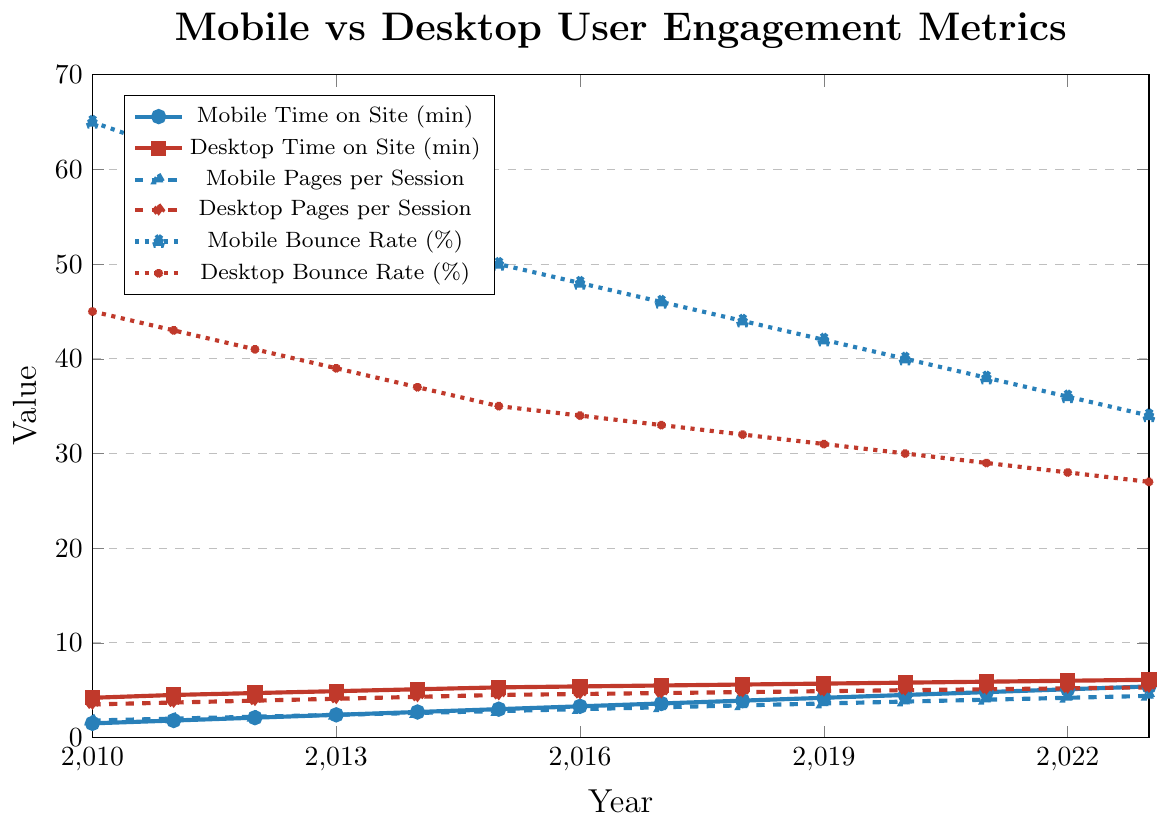What is the trend for mobile time on site from 2010 to 2023? The line chart shows an upward trend for mobile time on site from 1.5 minutes in 2010 to 5.4 minutes in 2023.
Answer: Increasing trend Which year had the smallest difference between mobile and desktop time on site? The difference between mobile and desktop time on site can be calculated for each year. The smallest difference is in 2023, where mobile time on site is 5.4 minutes and desktop is 6.1 minutes (difference of 0.7 minutes).
Answer: 2023 Between 2010 and 2023, which platform saw a larger reduction in bounce rate, mobile or desktop? The bounce rate for mobile decreased from 65% in 2010 to 34% in 2023 (31% reduction), while desktop decreased from 45% in 2010 to 27% in 2023 (18% reduction). Mobile saw a larger reduction.
Answer: Mobile What is the average pages per session for mobile users in 2023? The chart shows that the pages per session for mobile users in 2023 is 4.4.
Answer: 4.4 pages Compare the trend in bounce rates for mobile and desktop users over the years. Both mobile and desktop bounce rates show a downward trend from 2010 to 2023. Mobile bounce rate decreased from 65% to 34%, and desktop from 45% to 27%.
Answer: Downward trend for both What is the visual difference between mobile and desktop pages per session in 2015? The figure shows that in 2015, mobile pages per session is marked with a small triangle at 2.8, and desktop pages per session with a diamond at 4.5.
Answer: Mobile: 2.8, Desktop: 4.5 Is the time on site for desktop always higher than that for mobile across the years? The figure indicates that desktop time on site is consistently higher than mobile time on site from 2010 to 2023.
Answer: Yes Calculate the average bounce rate for mobile users over the entire period shown. Sum the mobile bounce rates from each year: 65 + 62 + 59 + 56 + 53 + 50 + 48 + 46 + 44 + 42 + 40 + 38 + 36 + 34 = 673. There are 14 years, so the average is 673 / 14.
Answer: 48.07% What year saw mobile pages per session surpass 3 for the first time? The figure shows that mobile pages per session surpassed 3 in 2016 with a value of 3.0.
Answer: 2016 